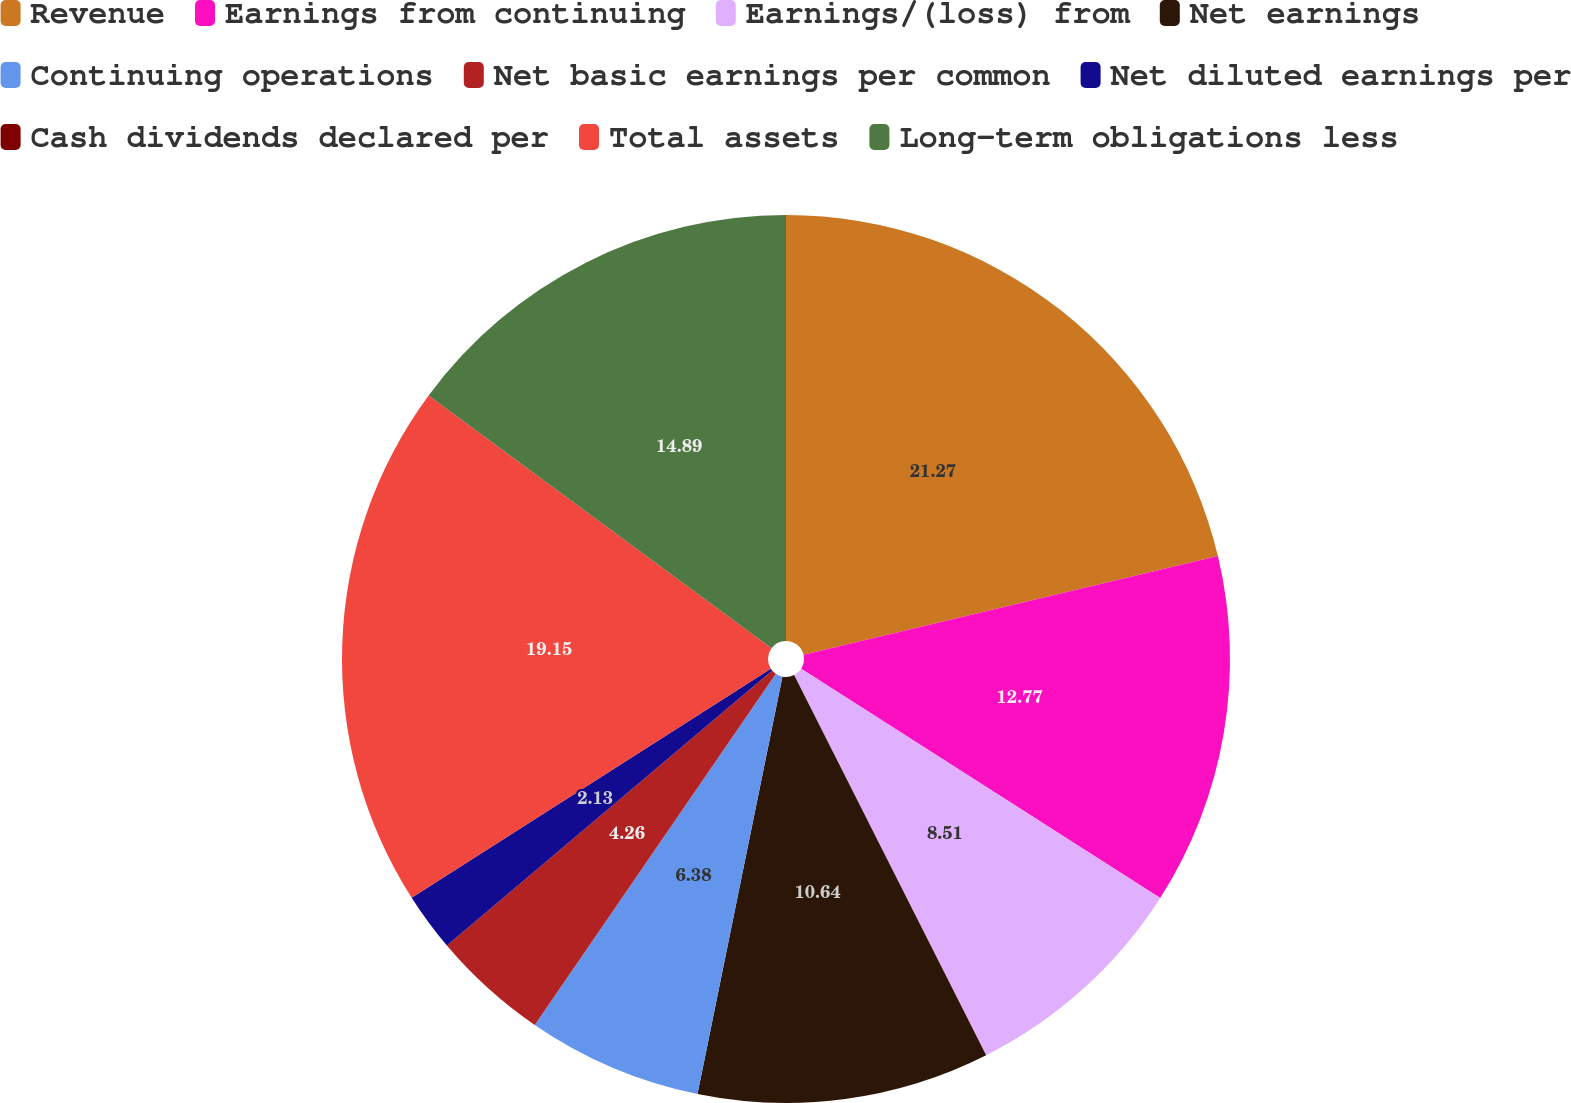Convert chart to OTSL. <chart><loc_0><loc_0><loc_500><loc_500><pie_chart><fcel>Revenue<fcel>Earnings from continuing<fcel>Earnings/(loss) from<fcel>Net earnings<fcel>Continuing operations<fcel>Net basic earnings per common<fcel>Net diluted earnings per<fcel>Cash dividends declared per<fcel>Total assets<fcel>Long-term obligations less<nl><fcel>21.28%<fcel>12.77%<fcel>8.51%<fcel>10.64%<fcel>6.38%<fcel>4.26%<fcel>2.13%<fcel>0.0%<fcel>19.15%<fcel>14.89%<nl></chart> 